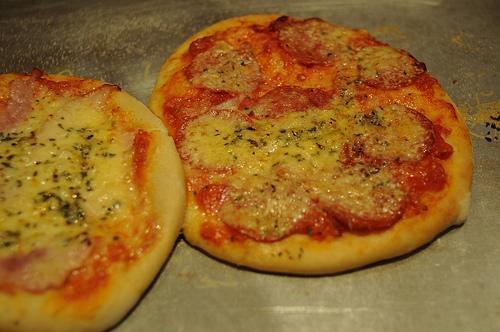How many pizzas are there?
Give a very brief answer. 2. 